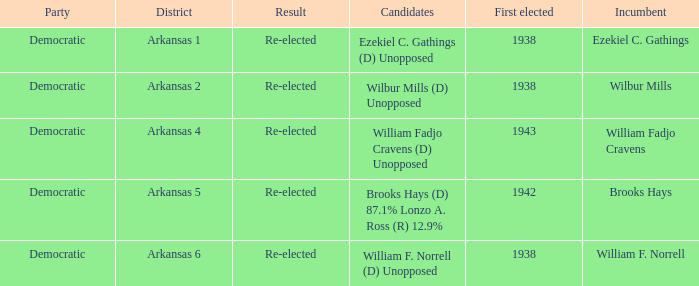What is the earliest years any of the incumbents were first elected?  1938.0. 